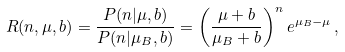<formula> <loc_0><loc_0><loc_500><loc_500>R ( n , \mu , b ) = \frac { P ( n | \mu , b ) } { P ( n | \mu _ { B } , b ) } = \left ( \frac { \mu + b } { \mu _ { B } + b } \right ) ^ { n } e ^ { \mu _ { B } - \mu } \, ,</formula> 